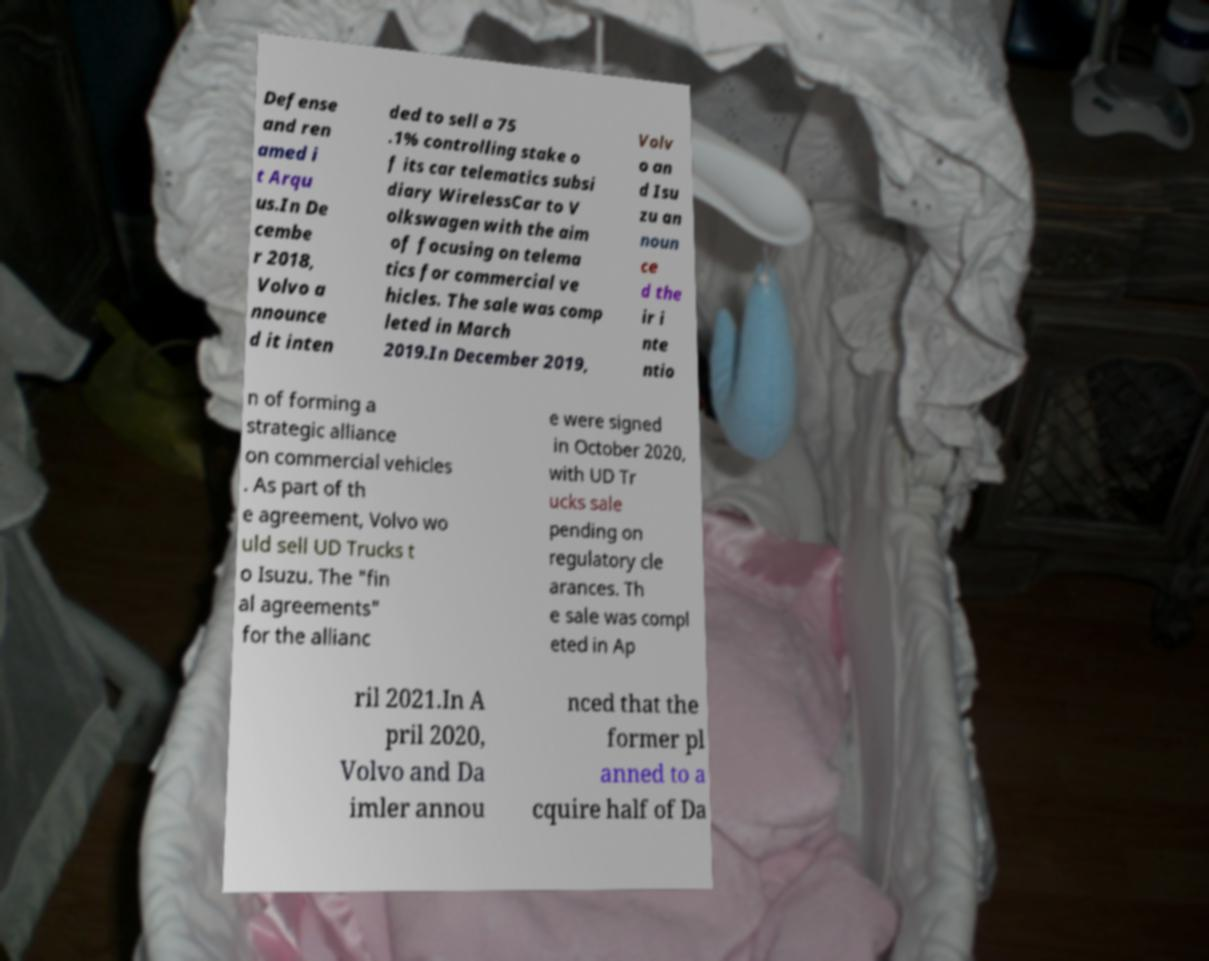Can you accurately transcribe the text from the provided image for me? Defense and ren amed i t Arqu us.In De cembe r 2018, Volvo a nnounce d it inten ded to sell a 75 .1% controlling stake o f its car telematics subsi diary WirelessCar to V olkswagen with the aim of focusing on telema tics for commercial ve hicles. The sale was comp leted in March 2019.In December 2019, Volv o an d Isu zu an noun ce d the ir i nte ntio n of forming a strategic alliance on commercial vehicles . As part of th e agreement, Volvo wo uld sell UD Trucks t o Isuzu. The "fin al agreements" for the allianc e were signed in October 2020, with UD Tr ucks sale pending on regulatory cle arances. Th e sale was compl eted in Ap ril 2021.In A pril 2020, Volvo and Da imler annou nced that the former pl anned to a cquire half of Da 